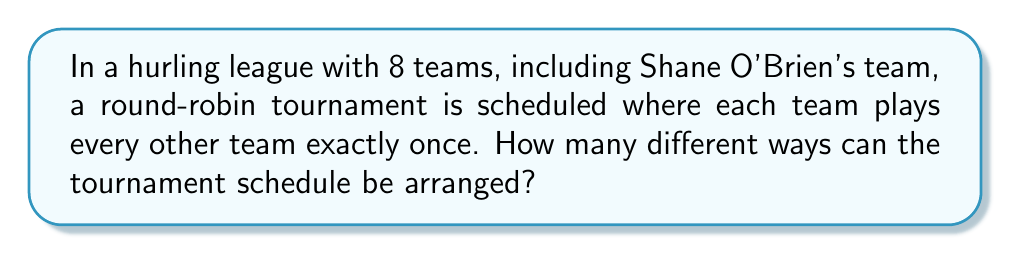Help me with this question. Let's approach this step-by-step:

1) In a round-robin tournament with 8 teams, each team plays 7 games (against every other team once).

2) The total number of games in the tournament is:
   $$\frac{8 \times 7}{2} = 28$$
   This is because each game is counted twice (once for each team involved), so we divide by 2.

3) Now, we need to determine how many ways we can arrange these 28 games.

4) This is equivalent to choosing 2 teams from 8 teams for each of the 28 games, where the order of selection within each game doesn't matter (Team A vs Team B is the same as Team B vs Team A).

5) The number of ways to choose 2 teams from 8 teams is given by the combination formula:
   $$\binom{8}{2} = \frac{8!}{2!(8-2)!} = \frac{8!}{2!6!} = 28$$

6) Now, we have 28 choices for the first game, 27 for the second, 26 for the third, and so on.

7) Therefore, the total number of possible schedules is:
   $$28 \times 27 \times 26 \times ... \times 2 \times 1 = 28!$$

This accounts for all possible arrangements of the 28 games in the tournament.
Answer: $28!$ 